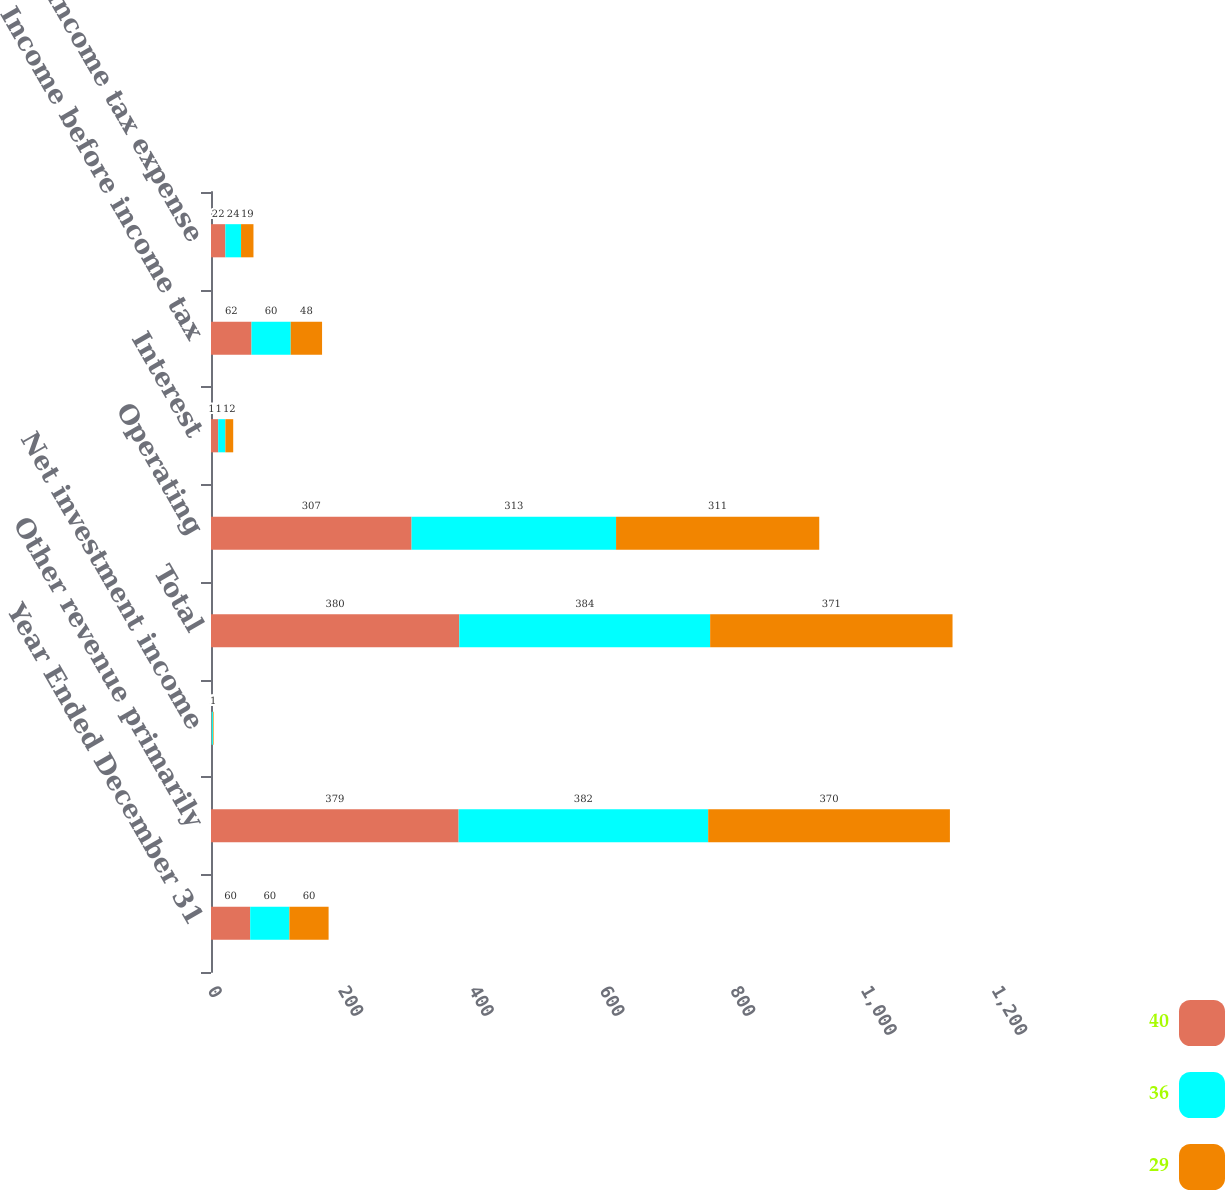Convert chart. <chart><loc_0><loc_0><loc_500><loc_500><stacked_bar_chart><ecel><fcel>Year Ended December 31<fcel>Other revenue primarily<fcel>Net investment income<fcel>Total<fcel>Operating<fcel>Interest<fcel>Income before income tax<fcel>Income tax expense<nl><fcel>40<fcel>60<fcel>379<fcel>1<fcel>380<fcel>307<fcel>11<fcel>62<fcel>22<nl><fcel>36<fcel>60<fcel>382<fcel>2<fcel>384<fcel>313<fcel>11<fcel>60<fcel>24<nl><fcel>29<fcel>60<fcel>370<fcel>1<fcel>371<fcel>311<fcel>12<fcel>48<fcel>19<nl></chart> 